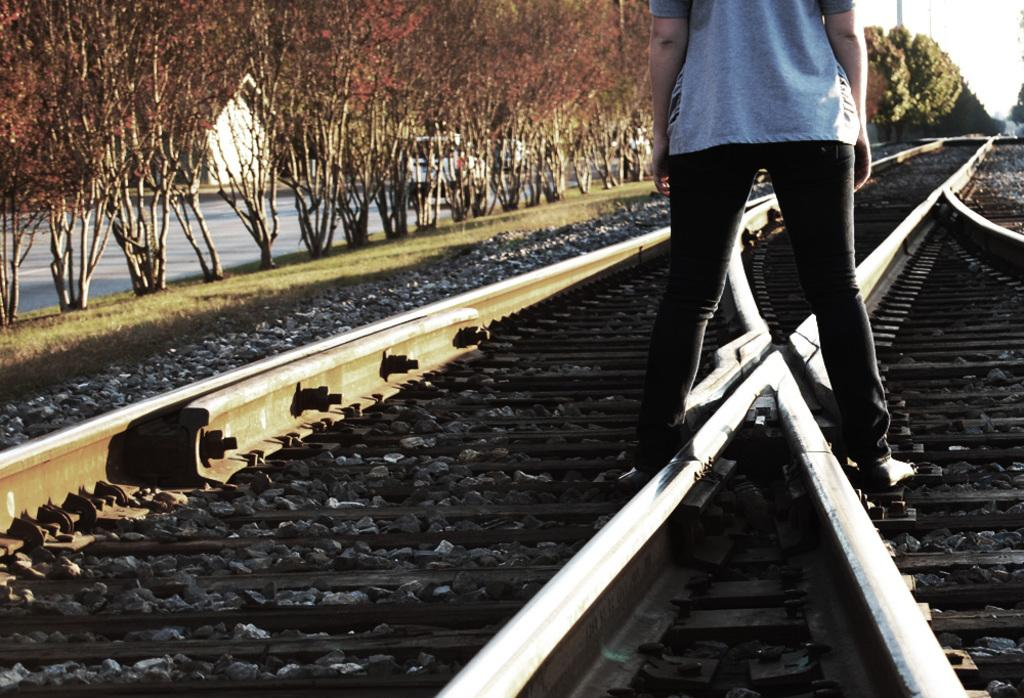What is the main subject in the foreground of the image? There is a person standing on the track in the foreground. What can be seen on the left side of the image? There are trees and a road on the left side of the image. What is visible at the top of the image? The sky is visible at the top of the image. Can you see a crib near the seashore in the image? There is no crib or seashore present in the image. 